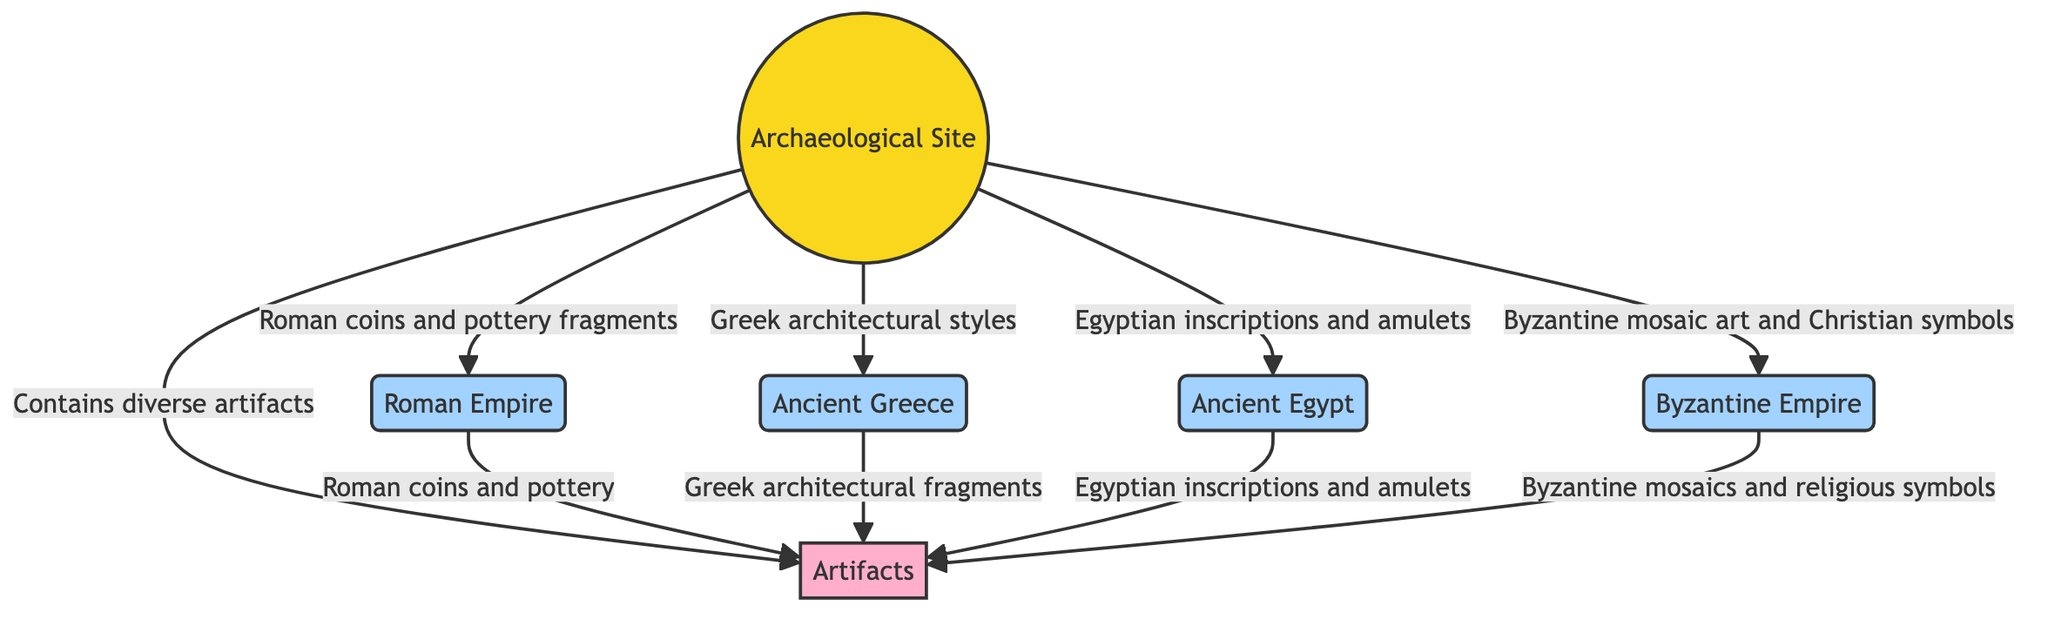What is the main site featured in the diagram? The main site is identified in the diagram as the "Archaeological Site." This is the central node and serves as the origin of the connections to the different civilizations.
Answer: Archaeological Site How many civilizations are connected to the archaeological site? By counting the nodes that represent different civilizations and their connections to the "Archaeological Site," we find there are four civilizations depicted: the Roman Empire, Ancient Greece, Ancient Egypt, and the Byzantine Empire.
Answer: 4 What type of influence is shown between the Roman Empire and the archaeological site? The relationship depicted is labeled as "Influence," and a specific description mentions "Roman coins and pottery fragments found at the site." This indicates the nature of interaction or contribution from this civilization.
Answer: Influence What artifacts are indicated to originate from the Byzantine Empire? According to the diagram, artifacts that originate from the Byzantine Empire include "Byzantine mosaics and religious symbols," which are specific items connecting the Byzantine culture to the site found.
Answer: Byzantine mosaics and religious symbols Which civilization shows evidence of architectural influence observed at the site? The diagram contains a connection labeled with a description "Greek architectural styles observed in structures," signifying the influence from Ancient Greece, specifically in terms of architecture.
Answer: Ancient Greece How are artifacts categorized in relation to the archaeological site? The diagram illustrates that the archaeological site "Contains" diverse artifacts and categorizes them as an element type, linking back to different civilizations that originate specific artifacts.
Answer: Contains What is the relationship between Ancient Egypt and artifacts at the site? The relationship illustrated shows that Ancient Egypt "Originates" artifacts which include "Egyptian inscriptions and amulets." This means these specific artifacts can be traced back to Ancient Egypt.
Answer: Originates How many total nodes are present in the diagram? The total number of nodes includes the archaeological site, four civilizations, and the artifacts node, leading to a sum of six nodes in total.
Answer: 6 